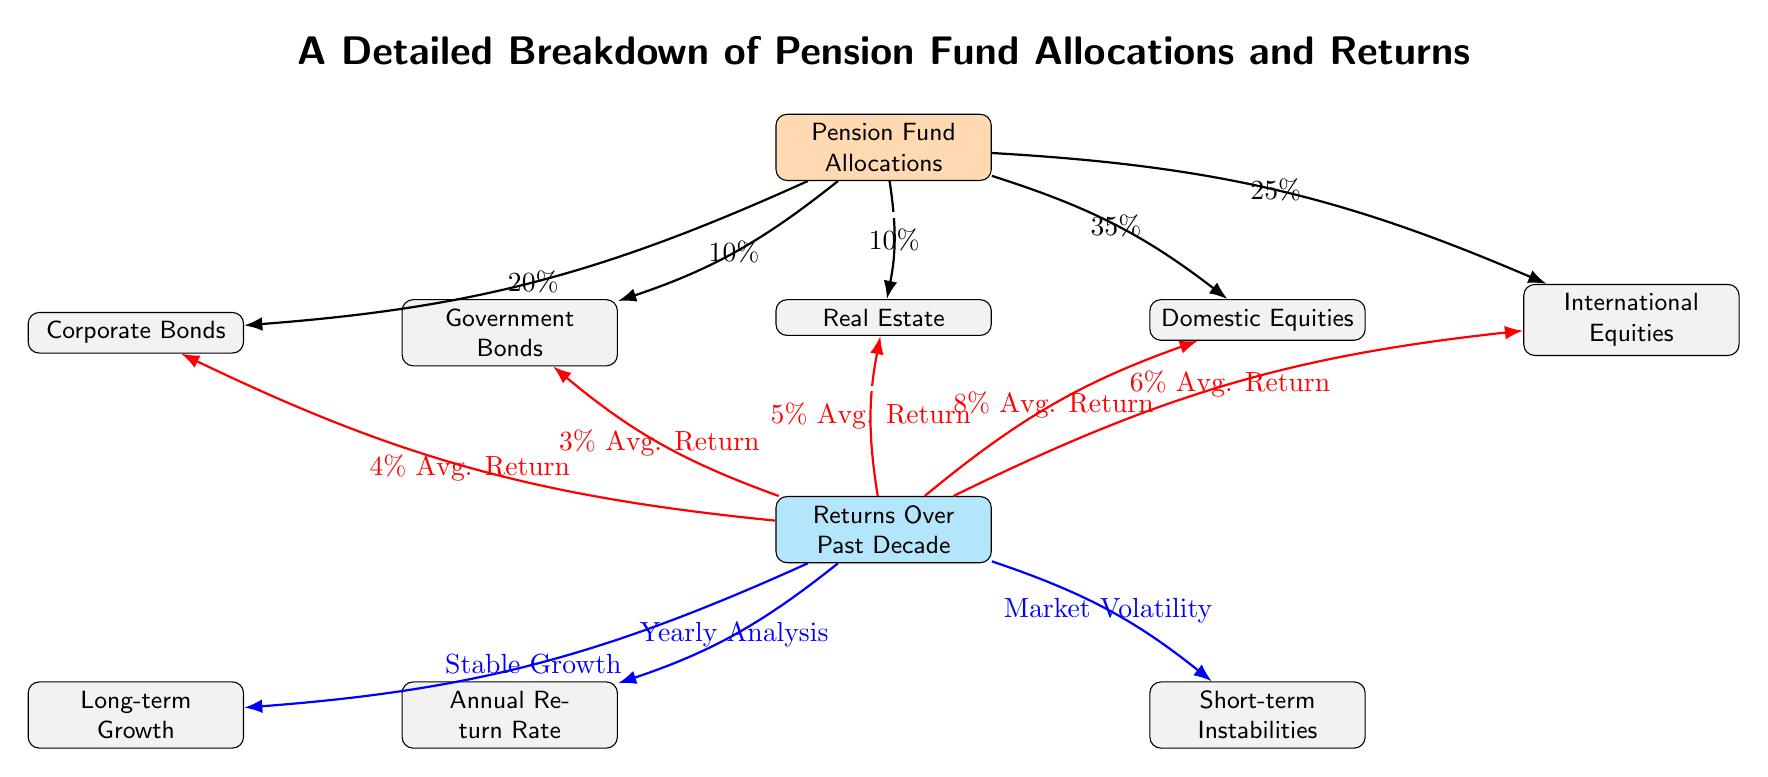What is the allocation percentage for Government Bonds? The diagram shows a direct connection from the "Pension Fund Allocations" node to the "Government Bonds" node, with a label indicating the allocation percentage as 10%.
Answer: 10% What is the highest average return percentage among the listed returns? By examining the average return percentages connected from the "Returns Over Past Decade" node, the "Domestic Equities" node shows an 8% average return, which is the highest compared to the other nodes.
Answer: 8% How many types of equity investments are represented in the diagram? The diagram features two types of equity investments: "Domestic Equities" and "International Equities." These can be counted directly by finding the relevant nodes within the "Pension Fund Allocations" section.
Answer: 2 What is the total percentage of allocations for Equities? To find this, we add the allocation percentages for both "Domestic Equities" (35%) and "International Equities" (25%) resulting in a total of 60%.
Answer: 60% Which type of return shows the lowest average return percentage? The "Government Bonds" node is connected to the "Returns Over Past Decade" node with a label indicating a 3% average return, which is the lowest compared to other investments.
Answer: 3% What is the main connection between "Returns Over Past Decade" and "Annual Return Rate"? There is a direct connection from the "Returns Over Past Decade" node to the "Annual Return Rate" node, showing a relation labeled as "Yearly Analysis," which implies that the annual return rate is derived from analyzing yearly performance data.
Answer: Yearly Analysis How is short-term instability indicated in the diagram? The "Returns Over Past Decade" node connects to the "Short-term Instabilities" node with a labeled connection, indicating that short-term fluctuations in returns can be attributed to market conditions or volatility issues.
Answer: Short-term Instabilities What is the most significant asset allocation category according to the diagram? The greatest allocation percentage is listed for "Domestic Equities" at 35%, indicating it is the most significant category among the asset allocations shown in the diagram.
Answer: Domestic Equities 